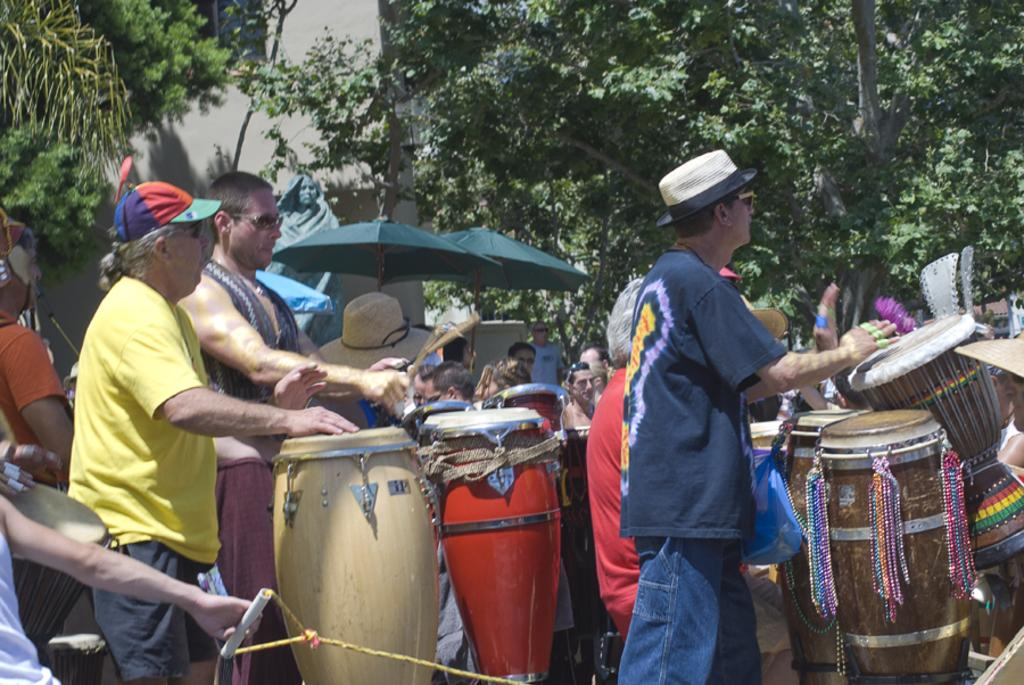What activity are the men in the image engaged in? The men in the image are playing drums. Are there any other people present in the image besides the drum players? Yes, there are people gathered around the drum players. What can be seen in the background of the image? There are trees and buildings in the background of the image. What type of advertisement can be seen near the drum players in the image? There is no advertisement present in the image; it features men playing drums and people gathered around them. 